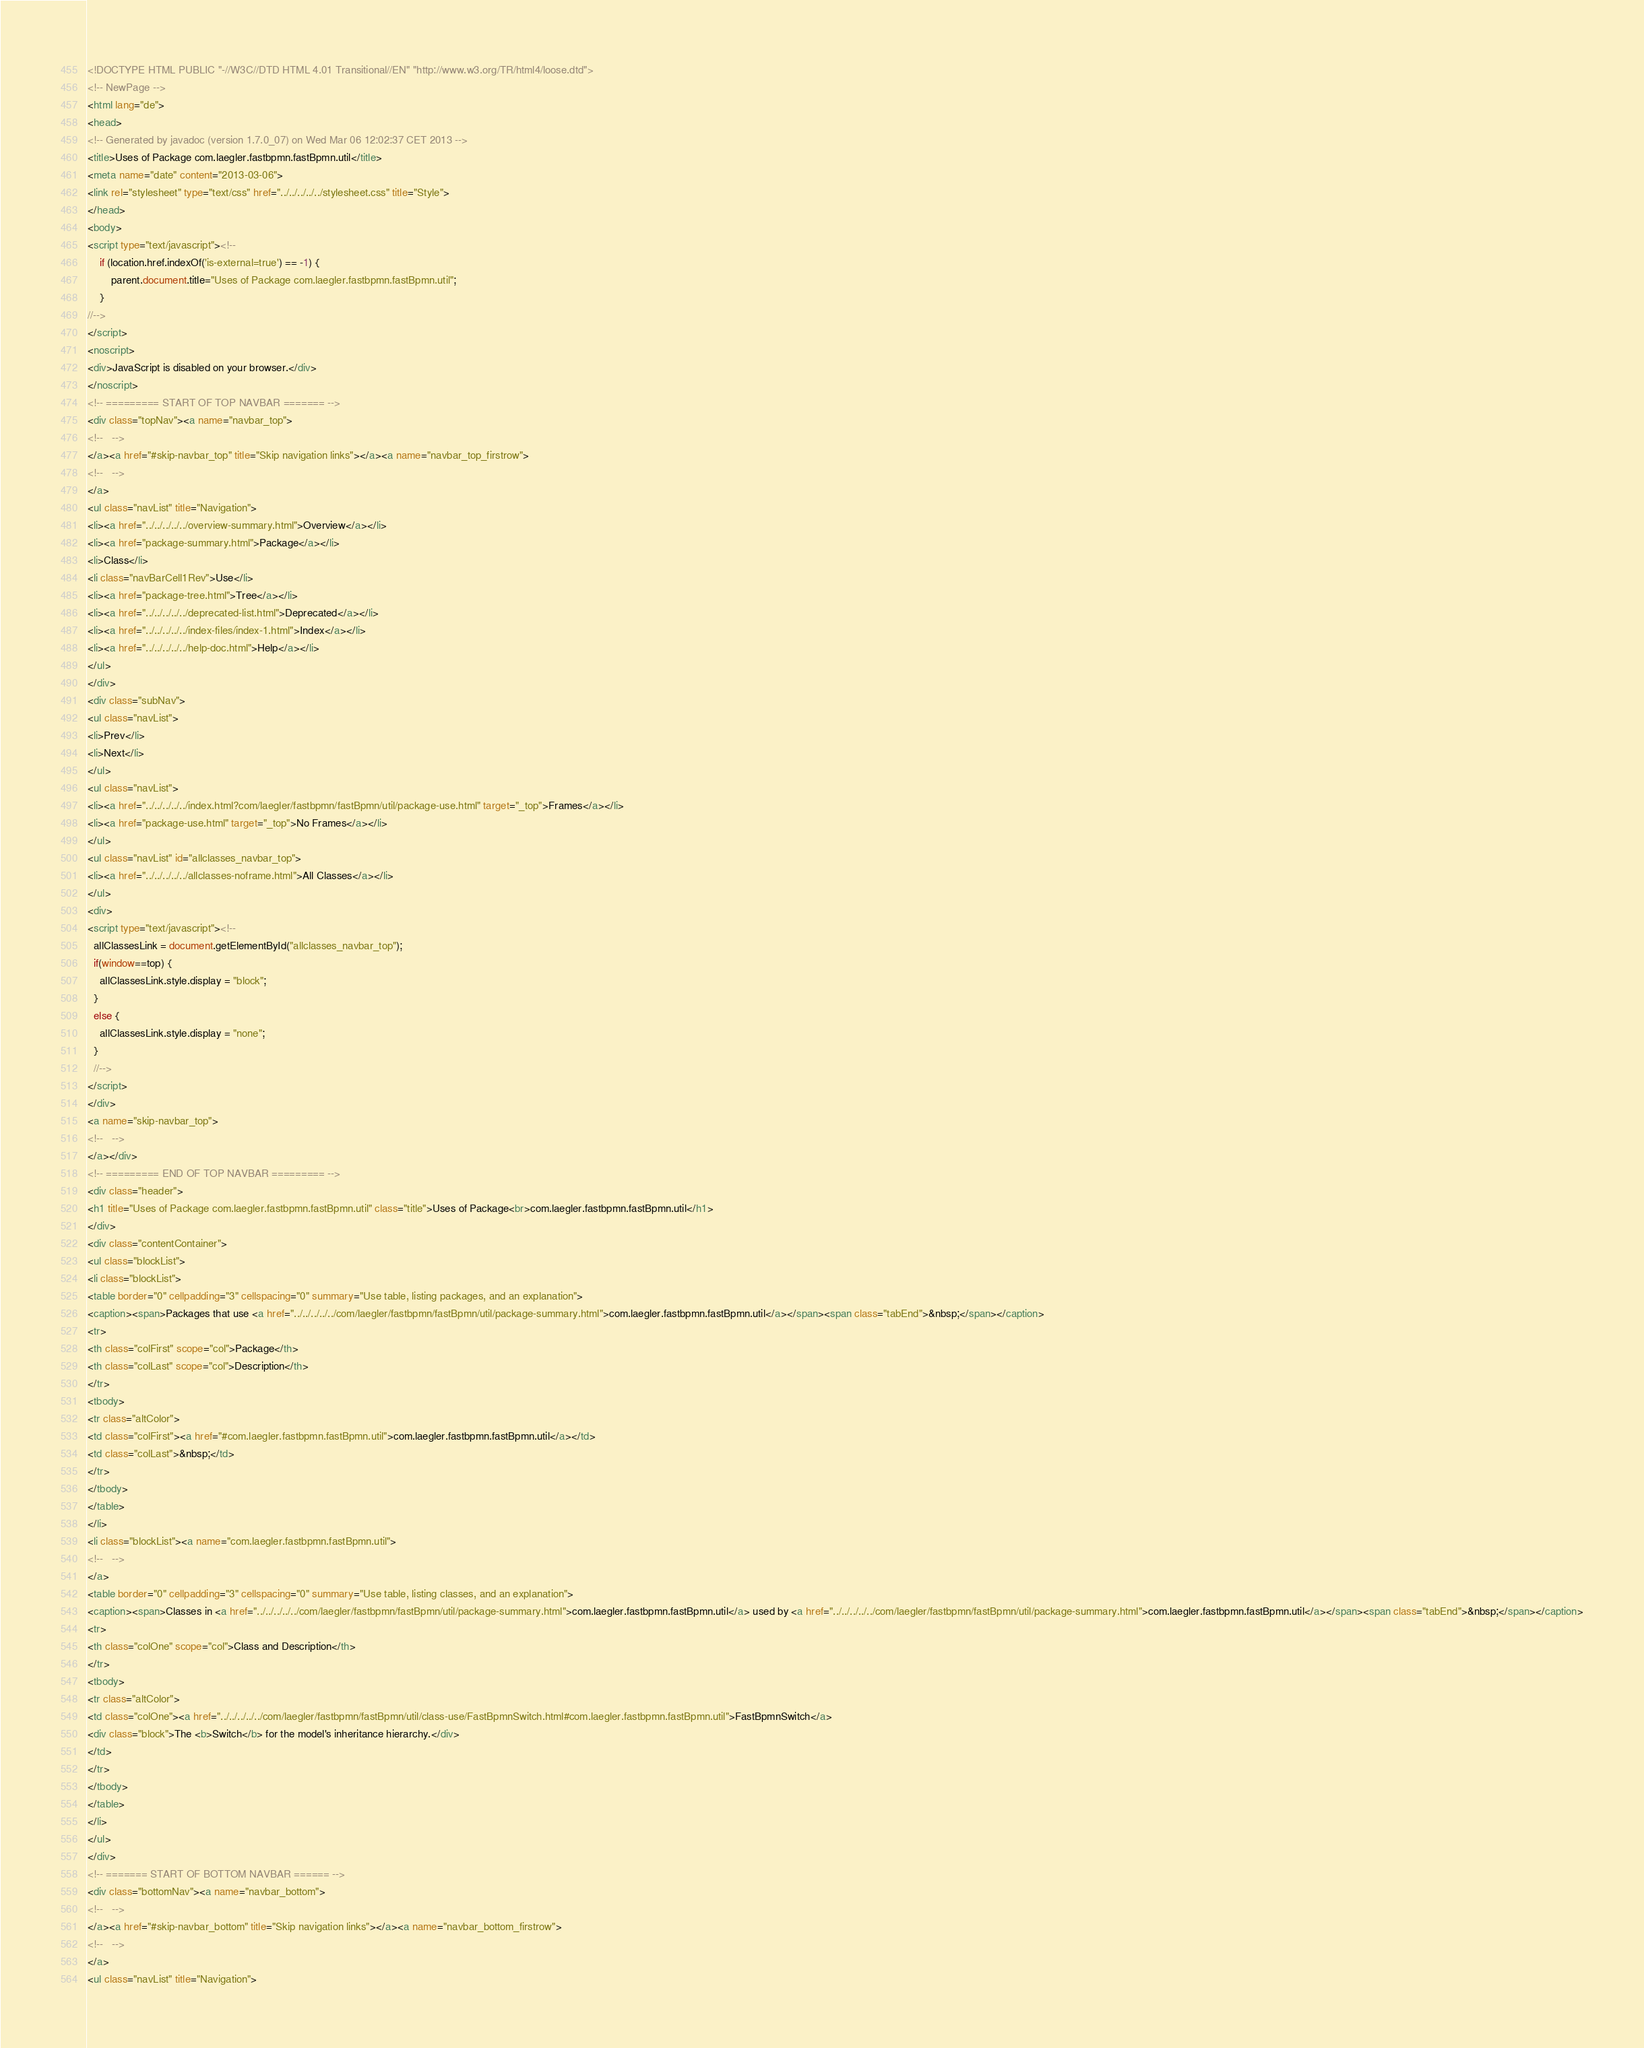<code> <loc_0><loc_0><loc_500><loc_500><_HTML_><!DOCTYPE HTML PUBLIC "-//W3C//DTD HTML 4.01 Transitional//EN" "http://www.w3.org/TR/html4/loose.dtd">
<!-- NewPage -->
<html lang="de">
<head>
<!-- Generated by javadoc (version 1.7.0_07) on Wed Mar 06 12:02:37 CET 2013 -->
<title>Uses of Package com.laegler.fastbpmn.fastBpmn.util</title>
<meta name="date" content="2013-03-06">
<link rel="stylesheet" type="text/css" href="../../../../../stylesheet.css" title="Style">
</head>
<body>
<script type="text/javascript"><!--
    if (location.href.indexOf('is-external=true') == -1) {
        parent.document.title="Uses of Package com.laegler.fastbpmn.fastBpmn.util";
    }
//-->
</script>
<noscript>
<div>JavaScript is disabled on your browser.</div>
</noscript>
<!-- ========= START OF TOP NAVBAR ======= -->
<div class="topNav"><a name="navbar_top">
<!--   -->
</a><a href="#skip-navbar_top" title="Skip navigation links"></a><a name="navbar_top_firstrow">
<!--   -->
</a>
<ul class="navList" title="Navigation">
<li><a href="../../../../../overview-summary.html">Overview</a></li>
<li><a href="package-summary.html">Package</a></li>
<li>Class</li>
<li class="navBarCell1Rev">Use</li>
<li><a href="package-tree.html">Tree</a></li>
<li><a href="../../../../../deprecated-list.html">Deprecated</a></li>
<li><a href="../../../../../index-files/index-1.html">Index</a></li>
<li><a href="../../../../../help-doc.html">Help</a></li>
</ul>
</div>
<div class="subNav">
<ul class="navList">
<li>Prev</li>
<li>Next</li>
</ul>
<ul class="navList">
<li><a href="../../../../../index.html?com/laegler/fastbpmn/fastBpmn/util/package-use.html" target="_top">Frames</a></li>
<li><a href="package-use.html" target="_top">No Frames</a></li>
</ul>
<ul class="navList" id="allclasses_navbar_top">
<li><a href="../../../../../allclasses-noframe.html">All Classes</a></li>
</ul>
<div>
<script type="text/javascript"><!--
  allClassesLink = document.getElementById("allclasses_navbar_top");
  if(window==top) {
    allClassesLink.style.display = "block";
  }
  else {
    allClassesLink.style.display = "none";
  }
  //-->
</script>
</div>
<a name="skip-navbar_top">
<!--   -->
</a></div>
<!-- ========= END OF TOP NAVBAR ========= -->
<div class="header">
<h1 title="Uses of Package com.laegler.fastbpmn.fastBpmn.util" class="title">Uses of Package<br>com.laegler.fastbpmn.fastBpmn.util</h1>
</div>
<div class="contentContainer">
<ul class="blockList">
<li class="blockList">
<table border="0" cellpadding="3" cellspacing="0" summary="Use table, listing packages, and an explanation">
<caption><span>Packages that use <a href="../../../../../com/laegler/fastbpmn/fastBpmn/util/package-summary.html">com.laegler.fastbpmn.fastBpmn.util</a></span><span class="tabEnd">&nbsp;</span></caption>
<tr>
<th class="colFirst" scope="col">Package</th>
<th class="colLast" scope="col">Description</th>
</tr>
<tbody>
<tr class="altColor">
<td class="colFirst"><a href="#com.laegler.fastbpmn.fastBpmn.util">com.laegler.fastbpmn.fastBpmn.util</a></td>
<td class="colLast">&nbsp;</td>
</tr>
</tbody>
</table>
</li>
<li class="blockList"><a name="com.laegler.fastbpmn.fastBpmn.util">
<!--   -->
</a>
<table border="0" cellpadding="3" cellspacing="0" summary="Use table, listing classes, and an explanation">
<caption><span>Classes in <a href="../../../../../com/laegler/fastbpmn/fastBpmn/util/package-summary.html">com.laegler.fastbpmn.fastBpmn.util</a> used by <a href="../../../../../com/laegler/fastbpmn/fastBpmn/util/package-summary.html">com.laegler.fastbpmn.fastBpmn.util</a></span><span class="tabEnd">&nbsp;</span></caption>
<tr>
<th class="colOne" scope="col">Class and Description</th>
</tr>
<tbody>
<tr class="altColor">
<td class="colOne"><a href="../../../../../com/laegler/fastbpmn/fastBpmn/util/class-use/FastBpmnSwitch.html#com.laegler.fastbpmn.fastBpmn.util">FastBpmnSwitch</a>
<div class="block">The <b>Switch</b> for the model's inheritance hierarchy.</div>
</td>
</tr>
</tbody>
</table>
</li>
</ul>
</div>
<!-- ======= START OF BOTTOM NAVBAR ====== -->
<div class="bottomNav"><a name="navbar_bottom">
<!--   -->
</a><a href="#skip-navbar_bottom" title="Skip navigation links"></a><a name="navbar_bottom_firstrow">
<!--   -->
</a>
<ul class="navList" title="Navigation"></code> 